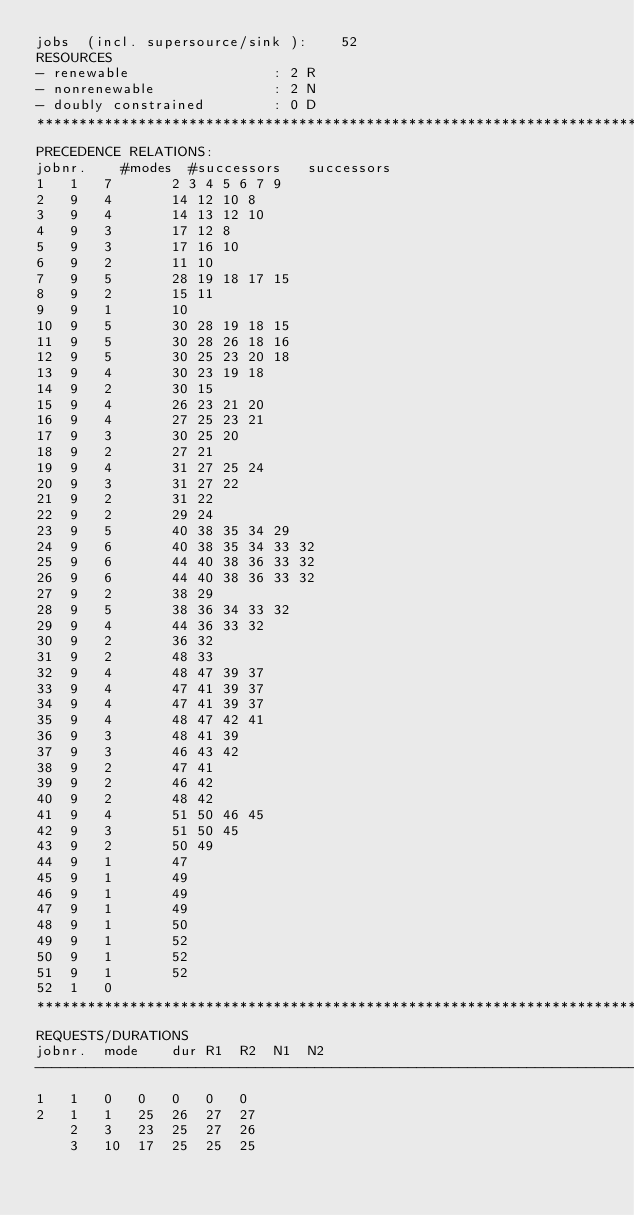Convert code to text. <code><loc_0><loc_0><loc_500><loc_500><_ObjectiveC_>jobs  (incl. supersource/sink ):	52
RESOURCES
- renewable                 : 2 R
- nonrenewable              : 2 N
- doubly constrained        : 0 D
************************************************************************
PRECEDENCE RELATIONS:
jobnr.    #modes  #successors   successors
1	1	7		2 3 4 5 6 7 9 
2	9	4		14 12 10 8 
3	9	4		14 13 12 10 
4	9	3		17 12 8 
5	9	3		17 16 10 
6	9	2		11 10 
7	9	5		28 19 18 17 15 
8	9	2		15 11 
9	9	1		10 
10	9	5		30 28 19 18 15 
11	9	5		30 28 26 18 16 
12	9	5		30 25 23 20 18 
13	9	4		30 23 19 18 
14	9	2		30 15 
15	9	4		26 23 21 20 
16	9	4		27 25 23 21 
17	9	3		30 25 20 
18	9	2		27 21 
19	9	4		31 27 25 24 
20	9	3		31 27 22 
21	9	2		31 22 
22	9	2		29 24 
23	9	5		40 38 35 34 29 
24	9	6		40 38 35 34 33 32 
25	9	6		44 40 38 36 33 32 
26	9	6		44 40 38 36 33 32 
27	9	2		38 29 
28	9	5		38 36 34 33 32 
29	9	4		44 36 33 32 
30	9	2		36 32 
31	9	2		48 33 
32	9	4		48 47 39 37 
33	9	4		47 41 39 37 
34	9	4		47 41 39 37 
35	9	4		48 47 42 41 
36	9	3		48 41 39 
37	9	3		46 43 42 
38	9	2		47 41 
39	9	2		46 42 
40	9	2		48 42 
41	9	4		51 50 46 45 
42	9	3		51 50 45 
43	9	2		50 49 
44	9	1		47 
45	9	1		49 
46	9	1		49 
47	9	1		49 
48	9	1		50 
49	9	1		52 
50	9	1		52 
51	9	1		52 
52	1	0		
************************************************************************
REQUESTS/DURATIONS
jobnr.	mode	dur	R1	R2	N1	N2	
------------------------------------------------------------------------
1	1	0	0	0	0	0	
2	1	1	25	26	27	27	
	2	3	23	25	27	26	
	3	10	17	25	25	25	</code> 